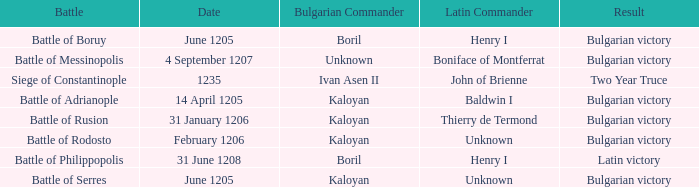What is the Result of the battle with Latin Commander Boniface of Montferrat? Bulgarian victory. 